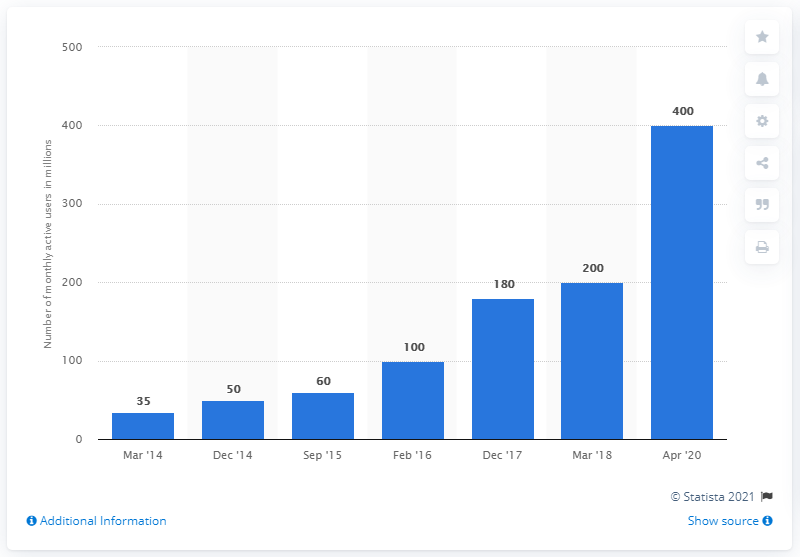Specify some key components in this picture. As of April 2020, Telegram had approximately 400 users. 